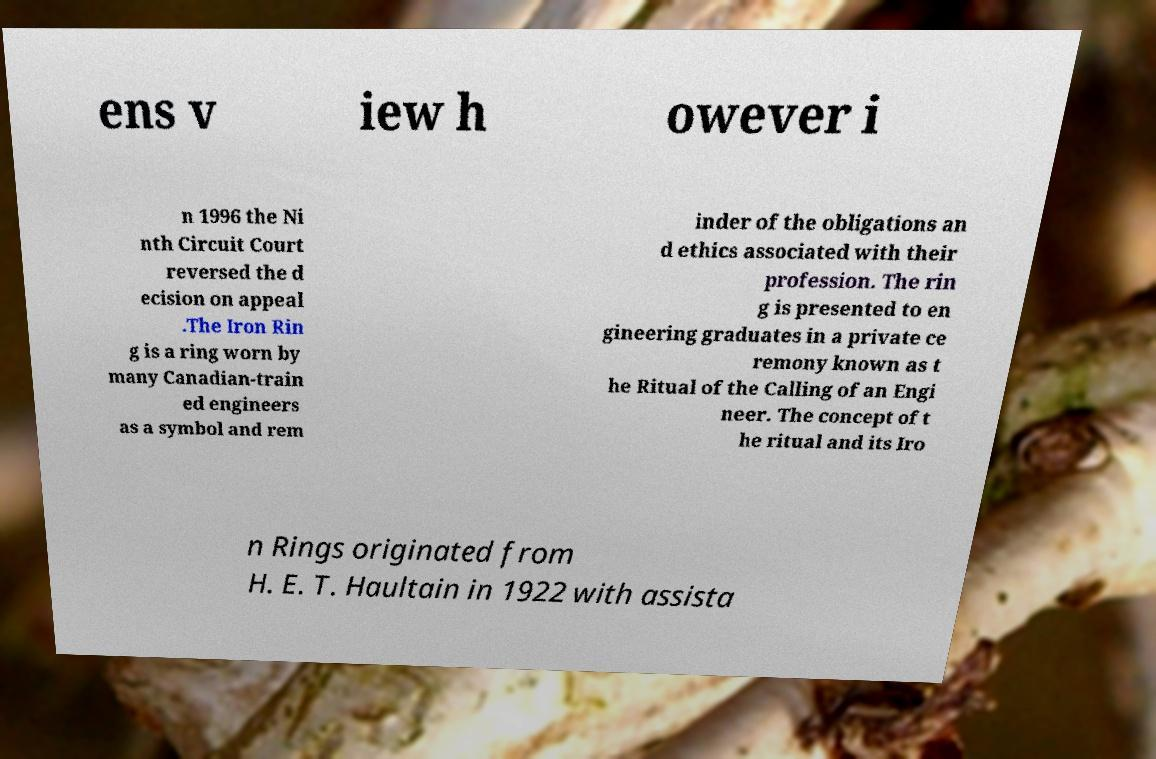For documentation purposes, I need the text within this image transcribed. Could you provide that? ens v iew h owever i n 1996 the Ni nth Circuit Court reversed the d ecision on appeal .The Iron Rin g is a ring worn by many Canadian-train ed engineers as a symbol and rem inder of the obligations an d ethics associated with their profession. The rin g is presented to en gineering graduates in a private ce remony known as t he Ritual of the Calling of an Engi neer. The concept of t he ritual and its Iro n Rings originated from H. E. T. Haultain in 1922 with assista 